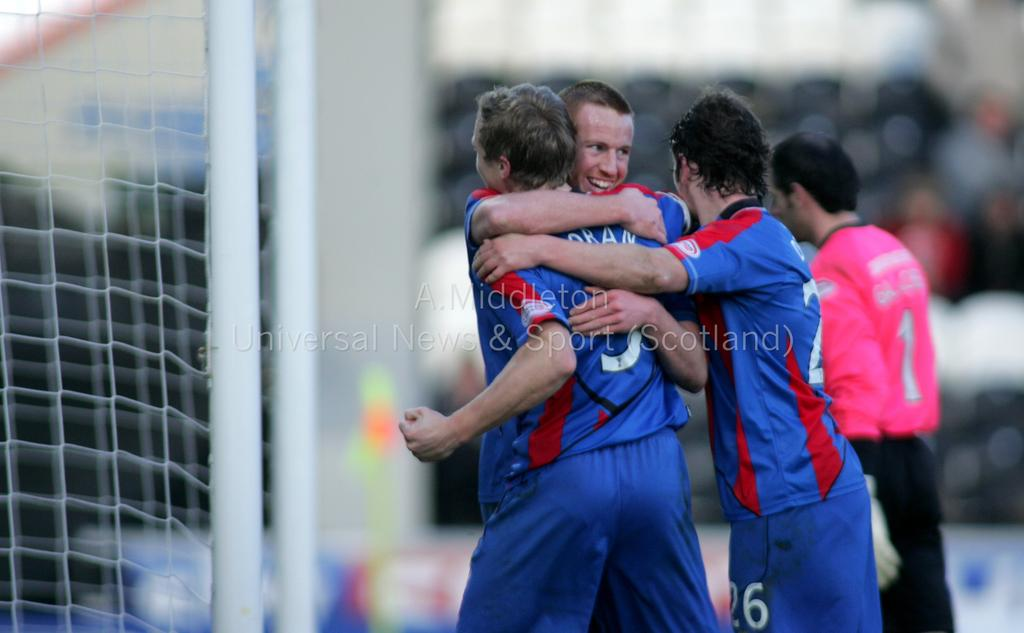<image>
Render a clear and concise summary of the photo. Players in blue jerseys, one wearing a 26, hug the player 5, Oran. 